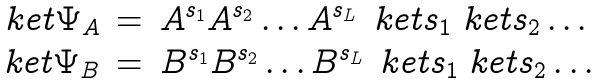Convert formula to latex. <formula><loc_0><loc_0><loc_500><loc_500>\begin{array} { r c l } \ k e t { \Psi _ { A } } & = & A ^ { s _ { 1 } } A ^ { s _ { 2 } } \dots A ^ { s _ { L } } \, \ k e t { s _ { 1 } } \ k e t { s _ { 2 } } \dots \\ \ k e t { \Psi _ { B } } & = & B ^ { s _ { 1 } } B ^ { s _ { 2 } } \dots B ^ { s _ { L } } \, \ k e t { s _ { 1 } } \ k e t { s _ { 2 } } \dots \\ \end{array}</formula> 